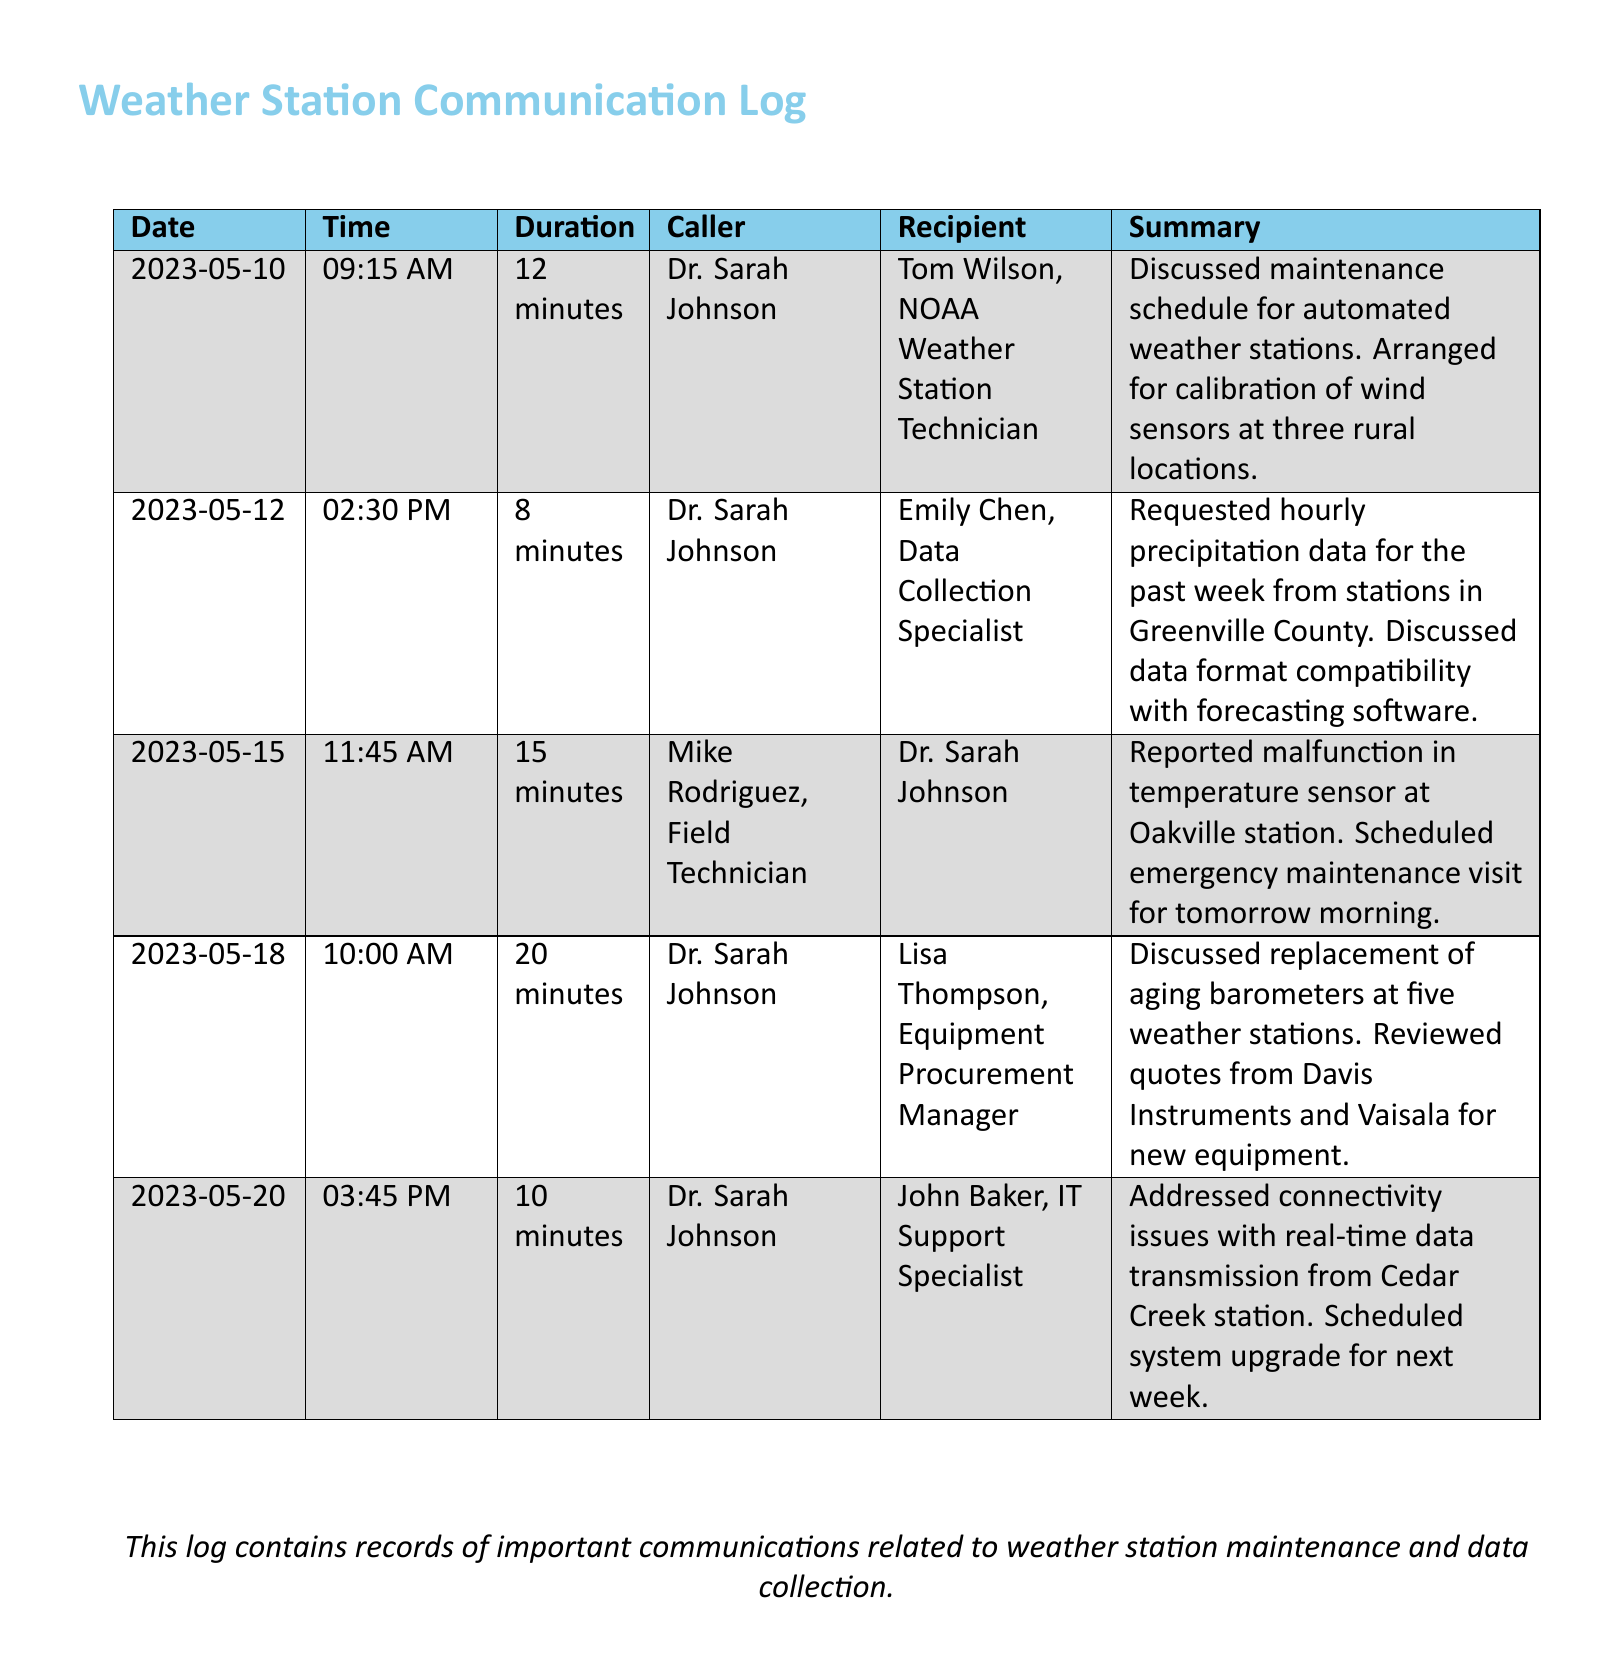what date was the call about the malfunctioning temperature sensor? The call regarding the malfunctioning temperature sensor took place on May 15, 2023.
Answer: May 15, 2023 who was the caller in the conversation regarding barometer replacement? The caller discussing the replacement of barometers was Dr. Sarah Johnson.
Answer: Dr. Sarah Johnson how long did the maintenance schedule discussion last? The discussion about the maintenance schedule lasted for 12 minutes.
Answer: 12 minutes which weather station was reported to have a temperature sensor malfunction? The Oakville station was reported to have a temperature sensor malfunction.
Answer: Oakville station who received the request for hourly precipitation data? Emily Chen, the Data Collection Specialist, received the request for hourly precipitation data.
Answer: Emily Chen what action was scheduled for the Cedar Creek station? A system upgrade was scheduled for the Cedar Creek station.
Answer: system upgrade how many weather stations were mentioned for barometer replacement? Five weather stations were mentioned for barometer replacement.
Answer: five which company provided quotes for new equipment? Quotes for new equipment were reviewed from Davis Instruments and Vaisala.
Answer: Davis Instruments and Vaisala what was the total duration of the calls made by Dr. Sarah Johnson in this document? The total duration of Dr. Sarah Johnson's calls in the document is 12 + 8 + 20 + 10 minutes, which sums up to 50 minutes.
Answer: 50 minutes 